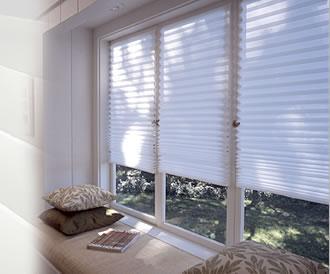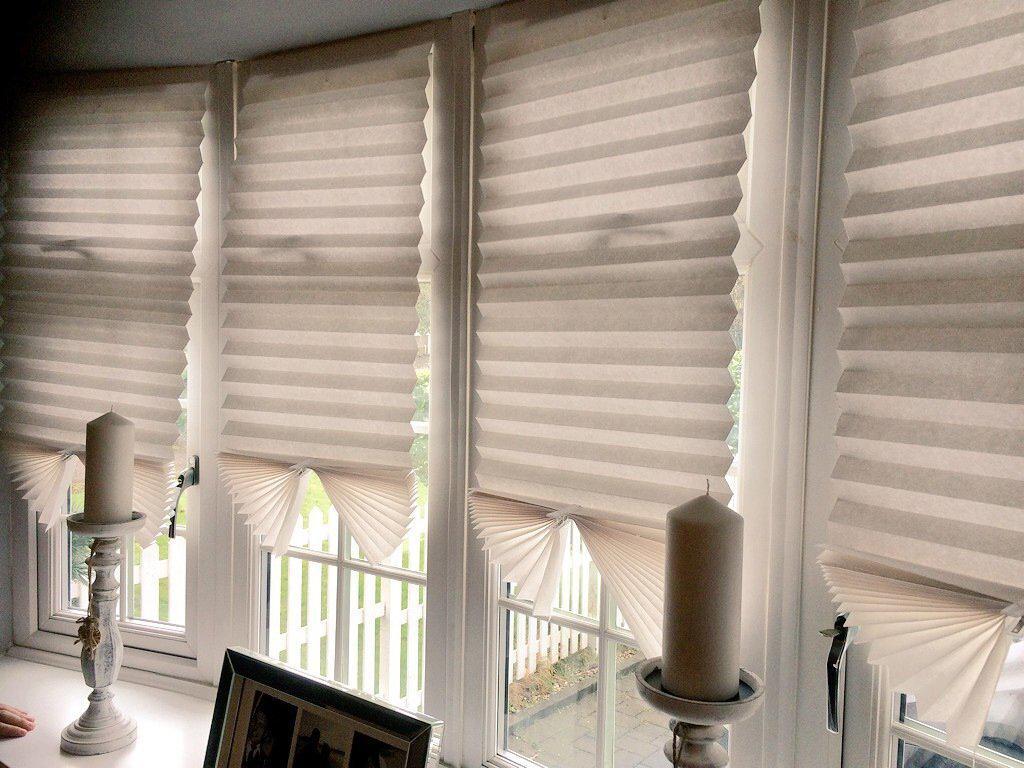The first image is the image on the left, the second image is the image on the right. Examine the images to the left and right. Is the description "There are exactly three shades." accurate? Answer yes or no. No. The first image is the image on the left, the second image is the image on the right. Examine the images to the left and right. Is the description "There are three blinds." accurate? Answer yes or no. No. 